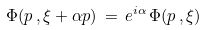<formula> <loc_0><loc_0><loc_500><loc_500>\Phi ( p \, , \xi + \alpha p ) \, = \, e ^ { i \alpha } \, \Phi ( p \, , \xi )</formula> 